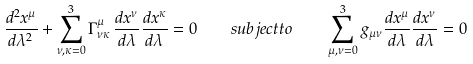<formula> <loc_0><loc_0><loc_500><loc_500>\frac { d ^ { 2 } x ^ { \mu } } { d \lambda ^ { 2 } } + \sum _ { \nu , \kappa = 0 } ^ { 3 } \Gamma _ { \nu \kappa } ^ { \mu } \, \frac { d x ^ { \nu } } { d \lambda } \frac { d x ^ { \kappa } } { d \lambda } = 0 \quad s u b j e c t t o \quad \sum _ { \mu , \nu = 0 } ^ { 3 } g _ { \mu \nu } \frac { d x ^ { \mu } } { d \lambda } \frac { d x ^ { \nu } } { d \lambda } = 0</formula> 